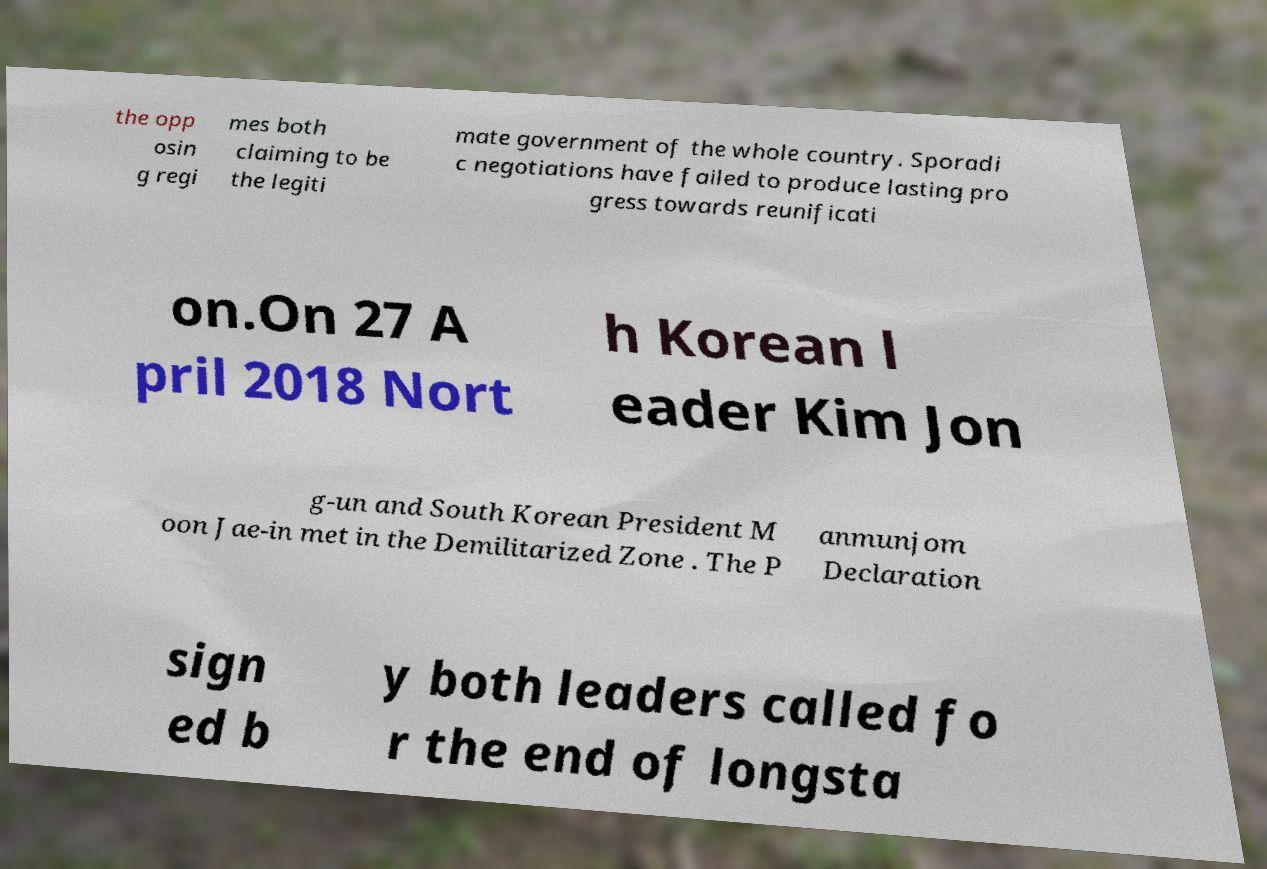Can you read and provide the text displayed in the image?This photo seems to have some interesting text. Can you extract and type it out for me? the opp osin g regi mes both claiming to be the legiti mate government of the whole country. Sporadi c negotiations have failed to produce lasting pro gress towards reunificati on.On 27 A pril 2018 Nort h Korean l eader Kim Jon g-un and South Korean President M oon Jae-in met in the Demilitarized Zone . The P anmunjom Declaration sign ed b y both leaders called fo r the end of longsta 